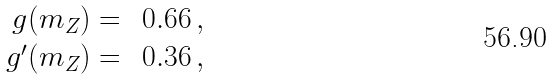<formula> <loc_0><loc_0><loc_500><loc_500>\begin{array} { r l } g ( m _ { Z } ) = & \, 0 . 6 6 \, , \\ g ^ { \prime } ( m _ { Z } ) = & \, 0 . 3 6 \, , \end{array}</formula> 